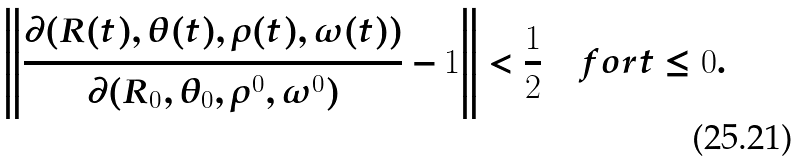<formula> <loc_0><loc_0><loc_500><loc_500>\left \| \frac { \partial ( R ( t ) , \theta ( t ) , \rho ( t ) , \omega ( t ) ) } { \partial ( R _ { 0 } , \theta _ { 0 } , \rho ^ { 0 } , \omega ^ { 0 } ) } - 1 \right \| < \frac { 1 } { 2 } \quad f o r t \leq 0 .</formula> 